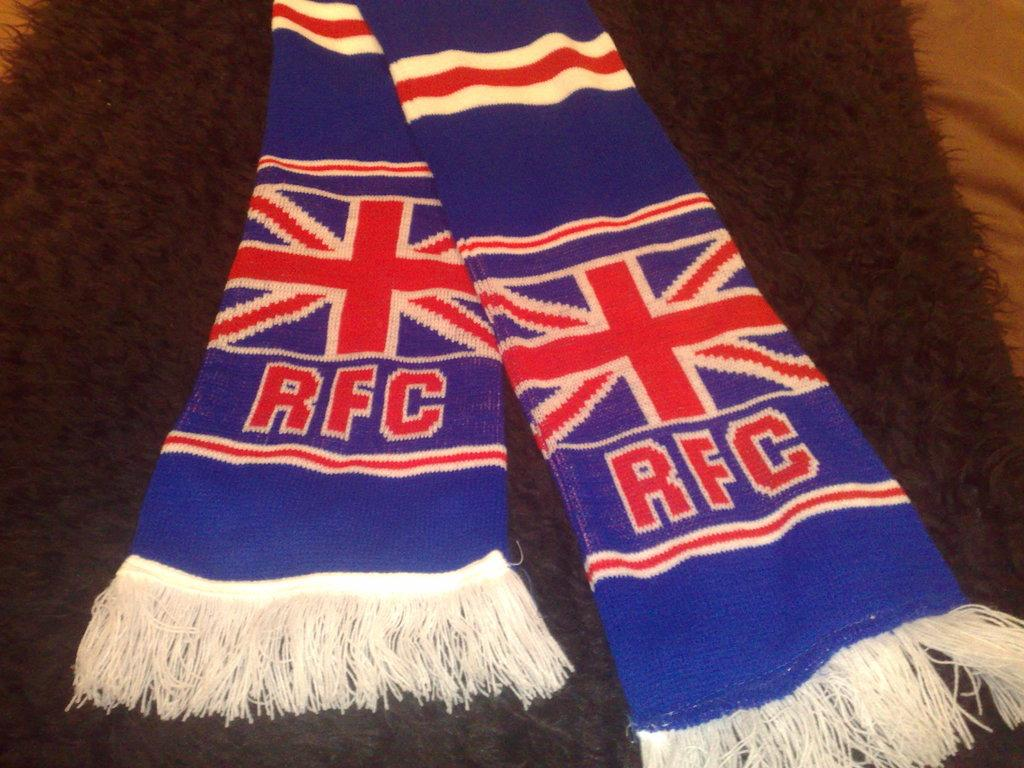<image>
Render a clear and concise summary of the photo. A scarf with a british flag with the RFC logo on it in red. 